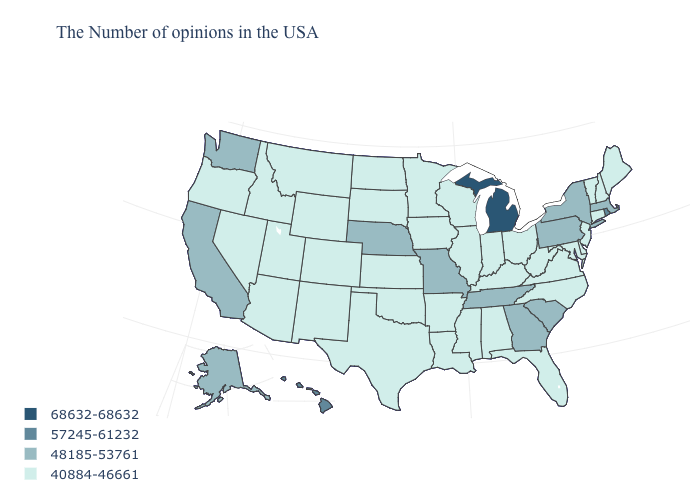What is the highest value in the MidWest ?
Keep it brief. 68632-68632. Does the first symbol in the legend represent the smallest category?
Answer briefly. No. What is the highest value in the USA?
Short answer required. 68632-68632. Does South Carolina have the lowest value in the USA?
Concise answer only. No. Name the states that have a value in the range 48185-53761?
Concise answer only. Massachusetts, New York, Pennsylvania, South Carolina, Georgia, Tennessee, Missouri, Nebraska, California, Washington, Alaska. Name the states that have a value in the range 48185-53761?
Answer briefly. Massachusetts, New York, Pennsylvania, South Carolina, Georgia, Tennessee, Missouri, Nebraska, California, Washington, Alaska. Does Arizona have the lowest value in the USA?
Be succinct. Yes. What is the value of Rhode Island?
Short answer required. 57245-61232. Does the map have missing data?
Quick response, please. No. Among the states that border Louisiana , which have the lowest value?
Keep it brief. Mississippi, Arkansas, Texas. Which states have the lowest value in the USA?
Answer briefly. Maine, New Hampshire, Vermont, Connecticut, New Jersey, Delaware, Maryland, Virginia, North Carolina, West Virginia, Ohio, Florida, Kentucky, Indiana, Alabama, Wisconsin, Illinois, Mississippi, Louisiana, Arkansas, Minnesota, Iowa, Kansas, Oklahoma, Texas, South Dakota, North Dakota, Wyoming, Colorado, New Mexico, Utah, Montana, Arizona, Idaho, Nevada, Oregon. What is the value of Texas?
Quick response, please. 40884-46661. What is the highest value in the USA?
Answer briefly. 68632-68632. 